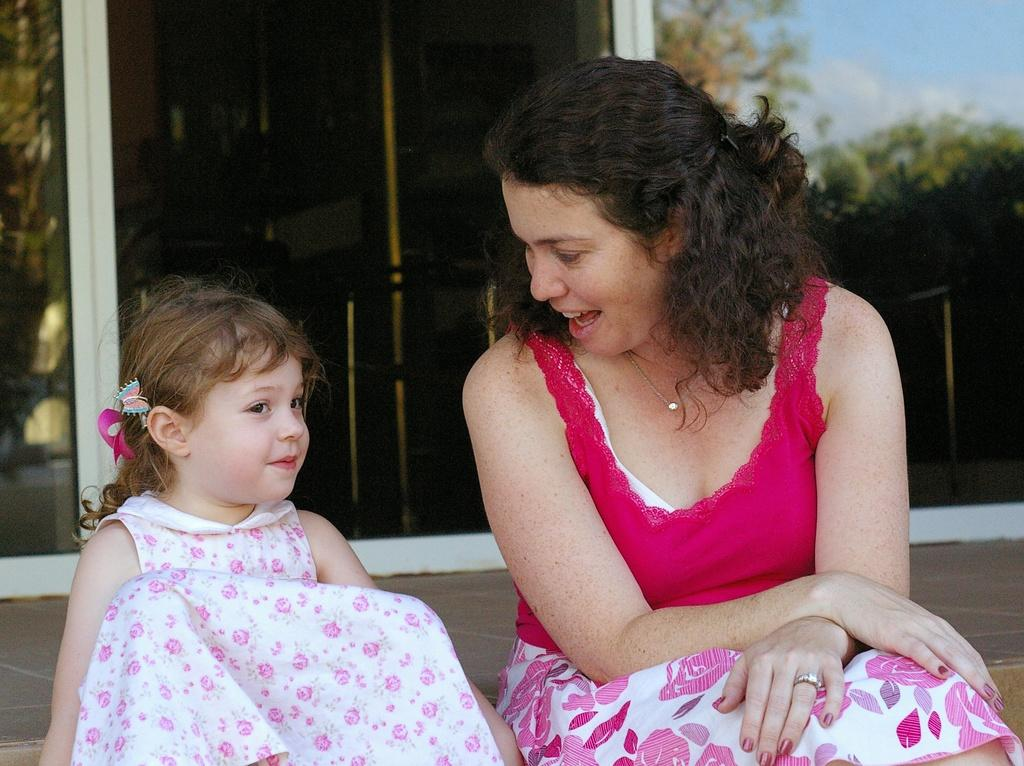Who is present in the image? There is a woman and a girl in the image. What are the woman and the girl doing in the image? The woman and the girl are sitting. What can be seen in the background of the image? There are items in the background of the image. What type of natural elements can be seen in the image? There is a reflection of trees and the sky in the image. What type of music can be heard in the image? There is no music present in the image, as it is a still photograph. What type of space-related objects can be seen in the image? There are no space-related objects present in the image; it features a woman and a girl sitting with a background of items and natural reflections. 